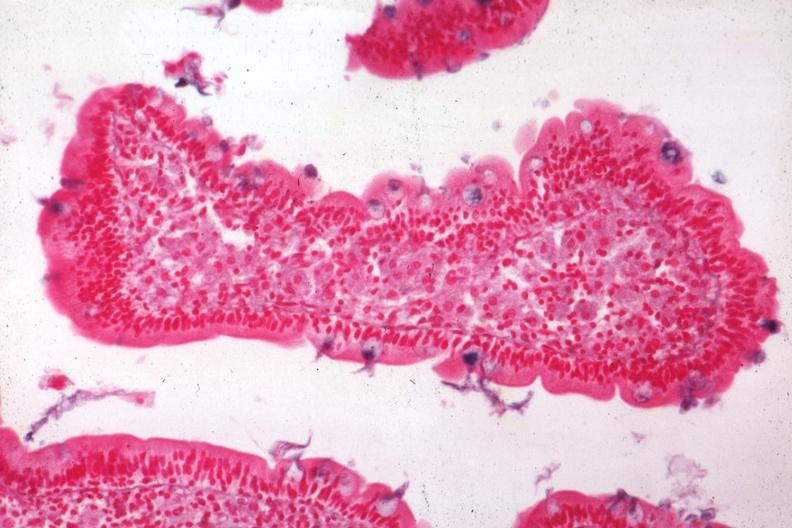how does this image show med alcian blue with apparently eosin counterstain enlarged villus?
Answer the question using a single word or phrase. Many macrophages source 